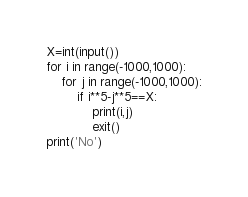<code> <loc_0><loc_0><loc_500><loc_500><_Python_>X=int(input())
for i in range(-1000,1000):
    for j in range(-1000,1000):
        if i**5-j**5==X:
            print(i,j)
            exit()
print('No')
</code> 